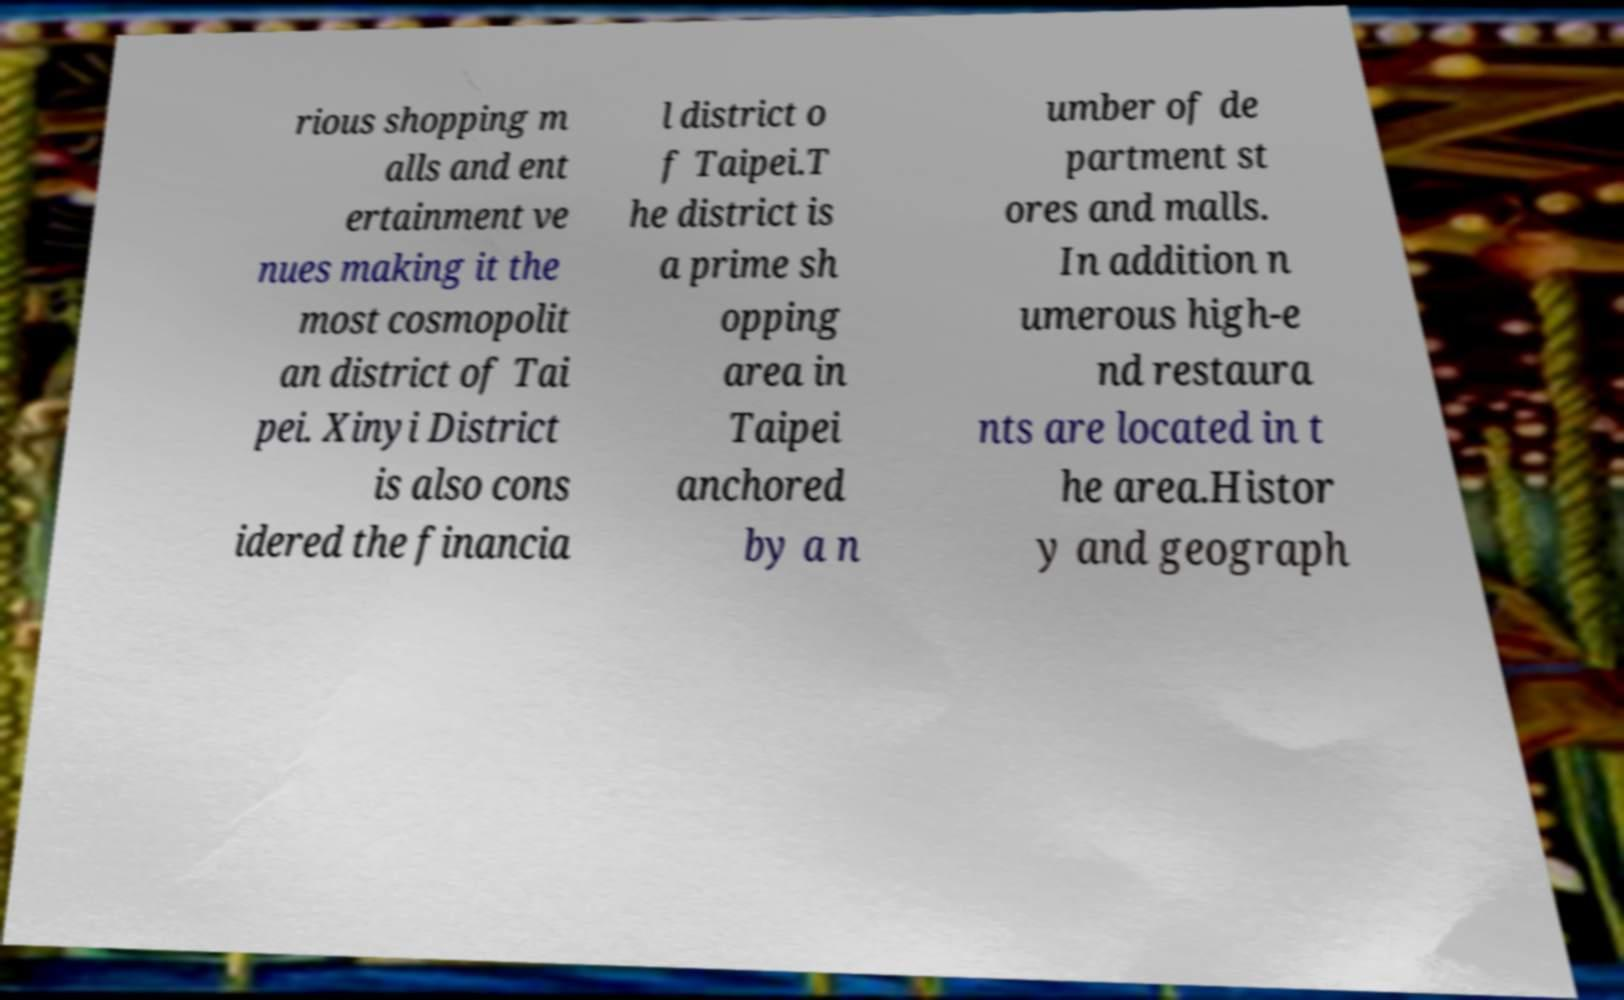For documentation purposes, I need the text within this image transcribed. Could you provide that? rious shopping m alls and ent ertainment ve nues making it the most cosmopolit an district of Tai pei. Xinyi District is also cons idered the financia l district o f Taipei.T he district is a prime sh opping area in Taipei anchored by a n umber of de partment st ores and malls. In addition n umerous high-e nd restaura nts are located in t he area.Histor y and geograph 